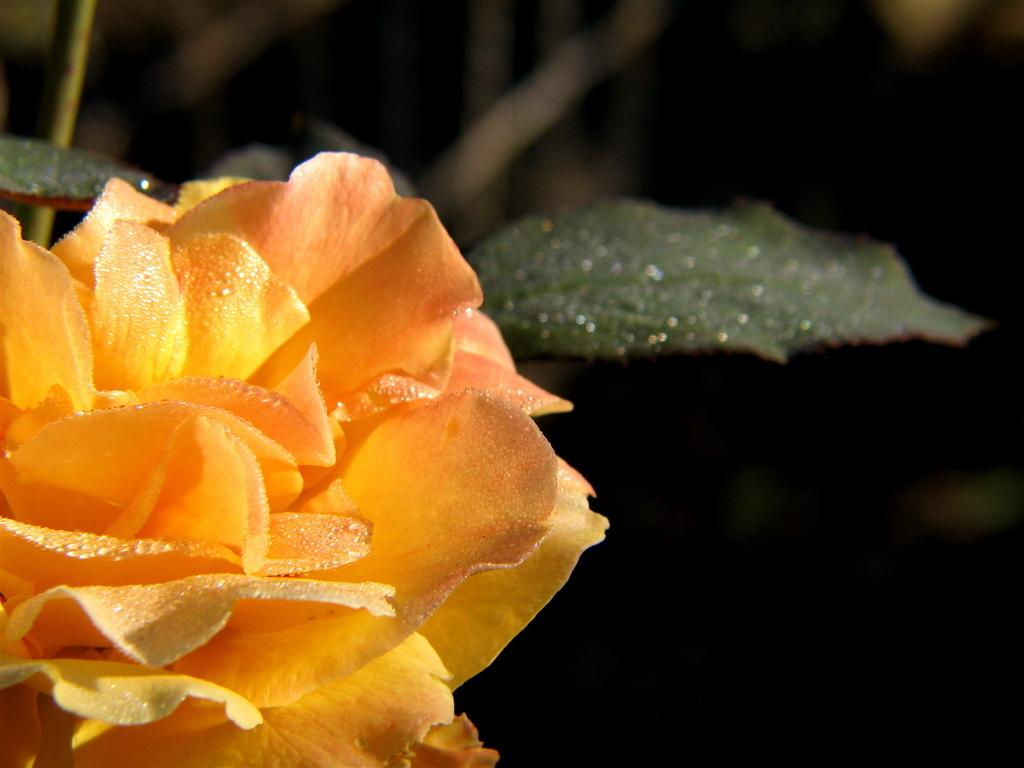What is located on the left side of the image? There is a flower on the left side of the image. What else can be seen in the image besides the flower? There are leaves in the image. How would you describe the overall appearance of the image? The background of the image is dark. What type of picture is hanging on the wall in the image? There is no wall or picture present in the image; it features a flower and leaves. Can you tell me where the elbow is located in the image? There is no elbow present in the image. 